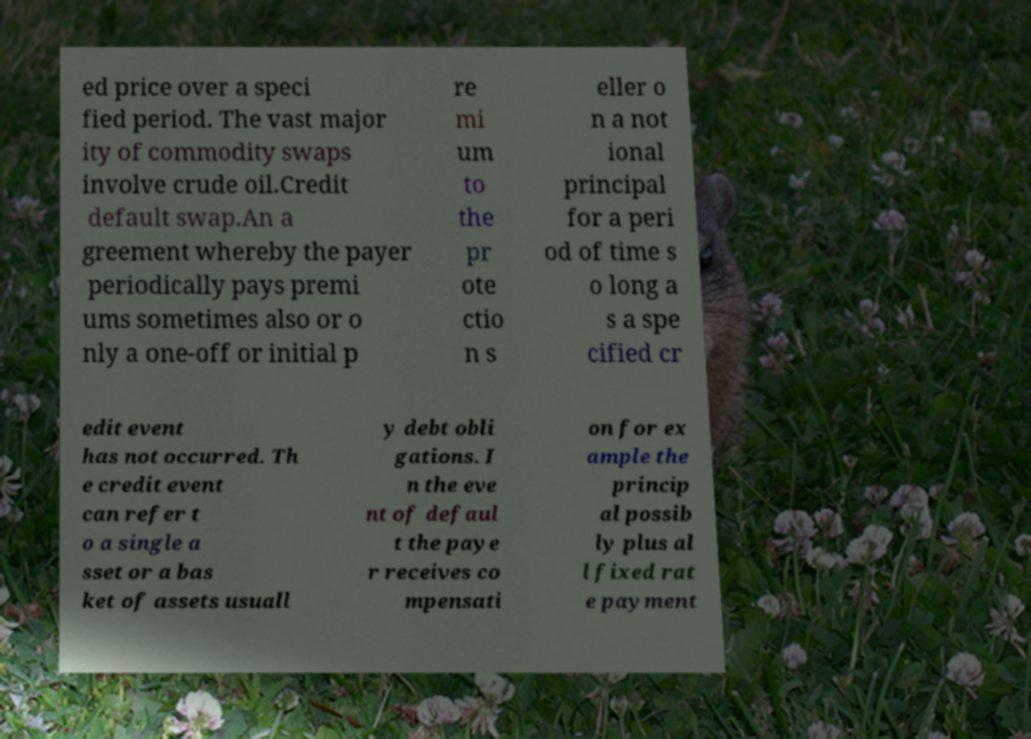I need the written content from this picture converted into text. Can you do that? ed price over a speci fied period. The vast major ity of commodity swaps involve crude oil.Credit default swap.An a greement whereby the payer periodically pays premi ums sometimes also or o nly a one-off or initial p re mi um to the pr ote ctio n s eller o n a not ional principal for a peri od of time s o long a s a spe cified cr edit event has not occurred. Th e credit event can refer t o a single a sset or a bas ket of assets usuall y debt obli gations. I n the eve nt of defaul t the paye r receives co mpensati on for ex ample the princip al possib ly plus al l fixed rat e payment 